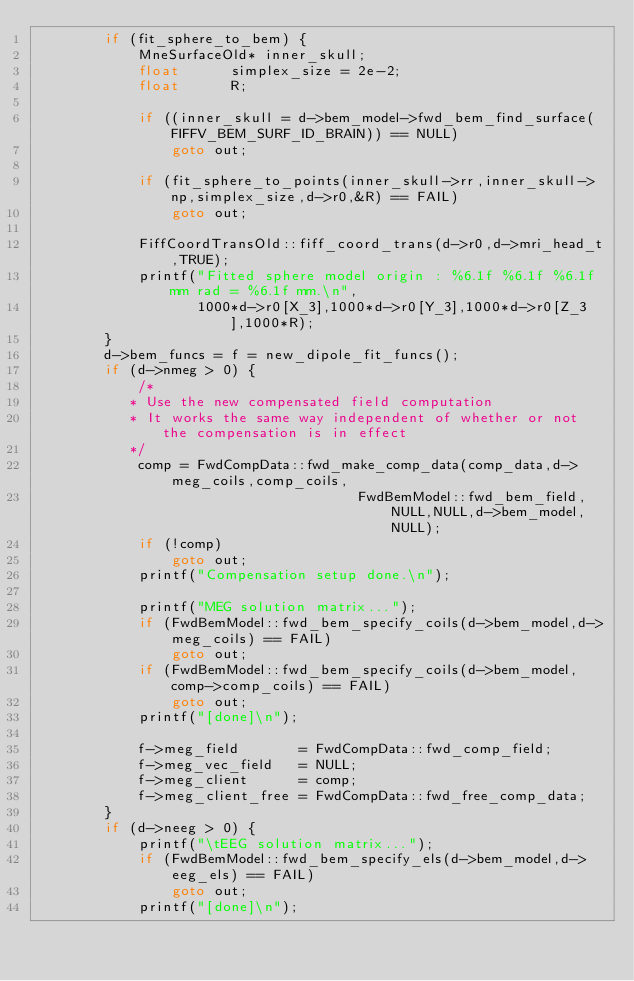<code> <loc_0><loc_0><loc_500><loc_500><_C++_>        if (fit_sphere_to_bem) {
            MneSurfaceOld* inner_skull;
            float      simplex_size = 2e-2;
            float      R;

            if ((inner_skull = d->bem_model->fwd_bem_find_surface(FIFFV_BEM_SURF_ID_BRAIN)) == NULL)
                goto out;

            if (fit_sphere_to_points(inner_skull->rr,inner_skull->np,simplex_size,d->r0,&R) == FAIL)
                goto out;

            FiffCoordTransOld::fiff_coord_trans(d->r0,d->mri_head_t,TRUE);
            printf("Fitted sphere model origin : %6.1f %6.1f %6.1f mm rad = %6.1f mm.\n",
                   1000*d->r0[X_3],1000*d->r0[Y_3],1000*d->r0[Z_3],1000*R);
        }
        d->bem_funcs = f = new_dipole_fit_funcs();
        if (d->nmeg > 0) {
            /*
           * Use the new compensated field computation
           * It works the same way independent of whether or not the compensation is in effect
           */
            comp = FwdCompData::fwd_make_comp_data(comp_data,d->meg_coils,comp_coils,
                                      FwdBemModel::fwd_bem_field,NULL,NULL,d->bem_model,NULL);
            if (!comp)
                goto out;
            printf("Compensation setup done.\n");

            printf("MEG solution matrix...");
            if (FwdBemModel::fwd_bem_specify_coils(d->bem_model,d->meg_coils) == FAIL)
                goto out;
            if (FwdBemModel::fwd_bem_specify_coils(d->bem_model,comp->comp_coils) == FAIL)
                goto out;
            printf("[done]\n");

            f->meg_field       = FwdCompData::fwd_comp_field;
            f->meg_vec_field   = NULL;
            f->meg_client      = comp;
            f->meg_client_free = FwdCompData::fwd_free_comp_data;
        }
        if (d->neeg > 0) {
            printf("\tEEG solution matrix...");
            if (FwdBemModel::fwd_bem_specify_els(d->bem_model,d->eeg_els) == FAIL)
                goto out;
            printf("[done]\n");</code> 